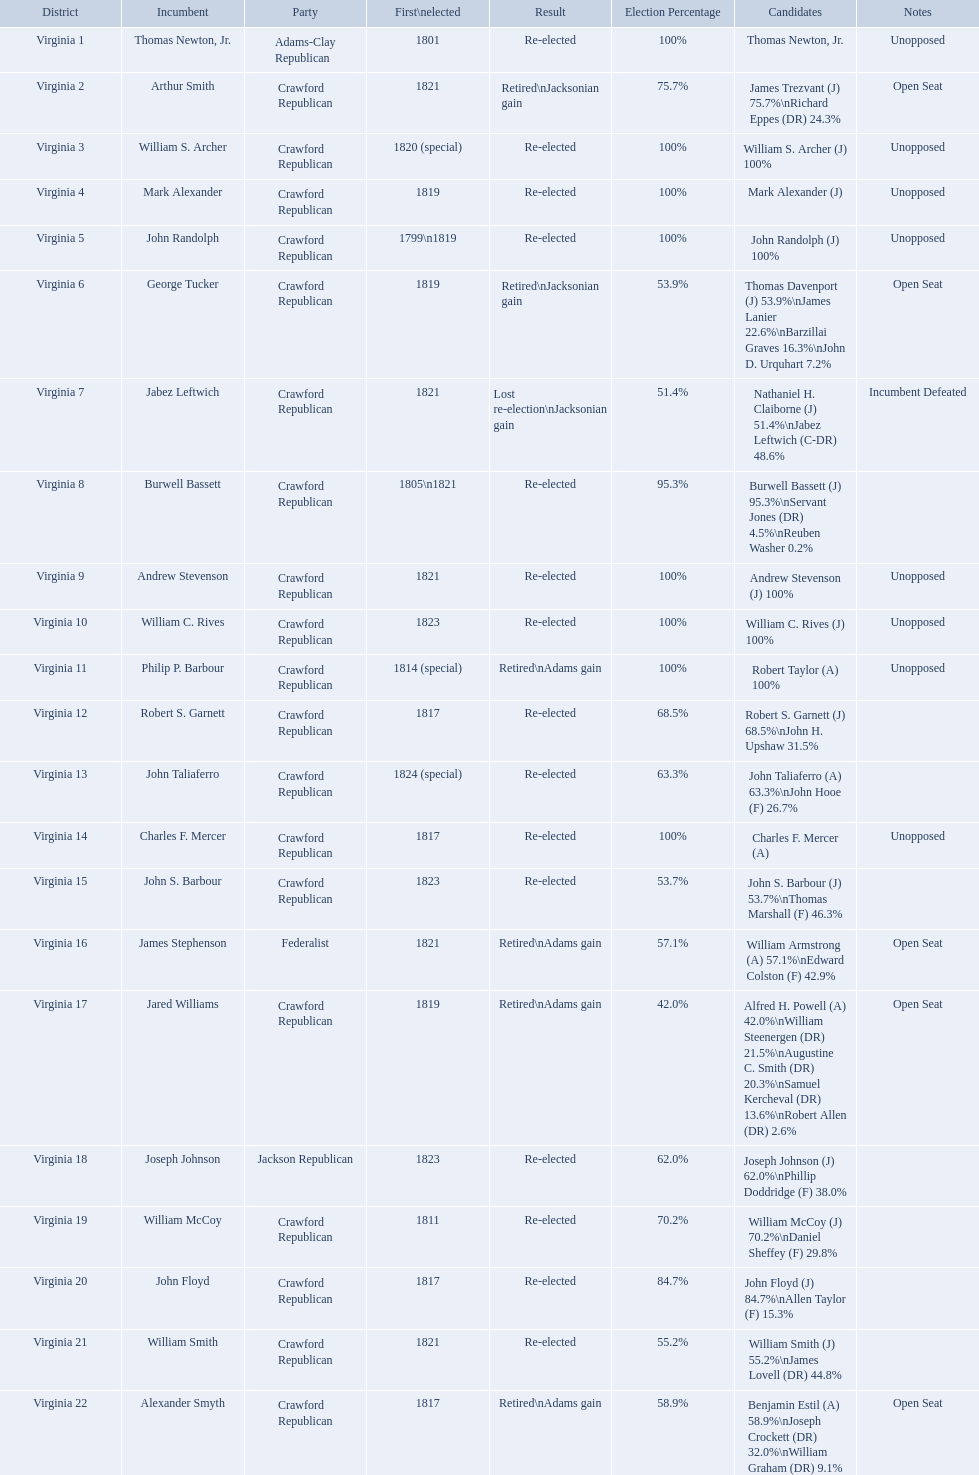What party is a crawford republican? Crawford Republican, Crawford Republican, Crawford Republican, Crawford Republican, Crawford Republican, Crawford Republican, Crawford Republican, Crawford Republican, Crawford Republican, Crawford Republican, Crawford Republican, Crawford Republican, Crawford Republican, Crawford Republican, Crawford Republican, Crawford Republican, Crawford Republican, Crawford Republican, Crawford Republican. What candidates have over 76%? James Trezvant (J) 75.7%\nRichard Eppes (DR) 24.3%, William S. Archer (J) 100%, John Randolph (J) 100%, Burwell Bassett (J) 95.3%\nServant Jones (DR) 4.5%\nReuben Washer 0.2%, Andrew Stevenson (J) 100%, William C. Rives (J) 100%, Robert Taylor (A) 100%, John Floyd (J) 84.7%\nAllen Taylor (F) 15.3%. Which result was retired jacksonian gain? Retired\nJacksonian gain. Who was the incumbent? Arthur Smith. 